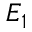Convert formula to latex. <formula><loc_0><loc_0><loc_500><loc_500>E _ { 1 }</formula> 